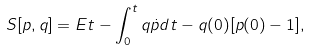Convert formula to latex. <formula><loc_0><loc_0><loc_500><loc_500>S [ p , q ] = E t - \int _ { 0 } ^ { t } q \dot { p } d t - q ( 0 ) [ p ( 0 ) - 1 ] ,</formula> 